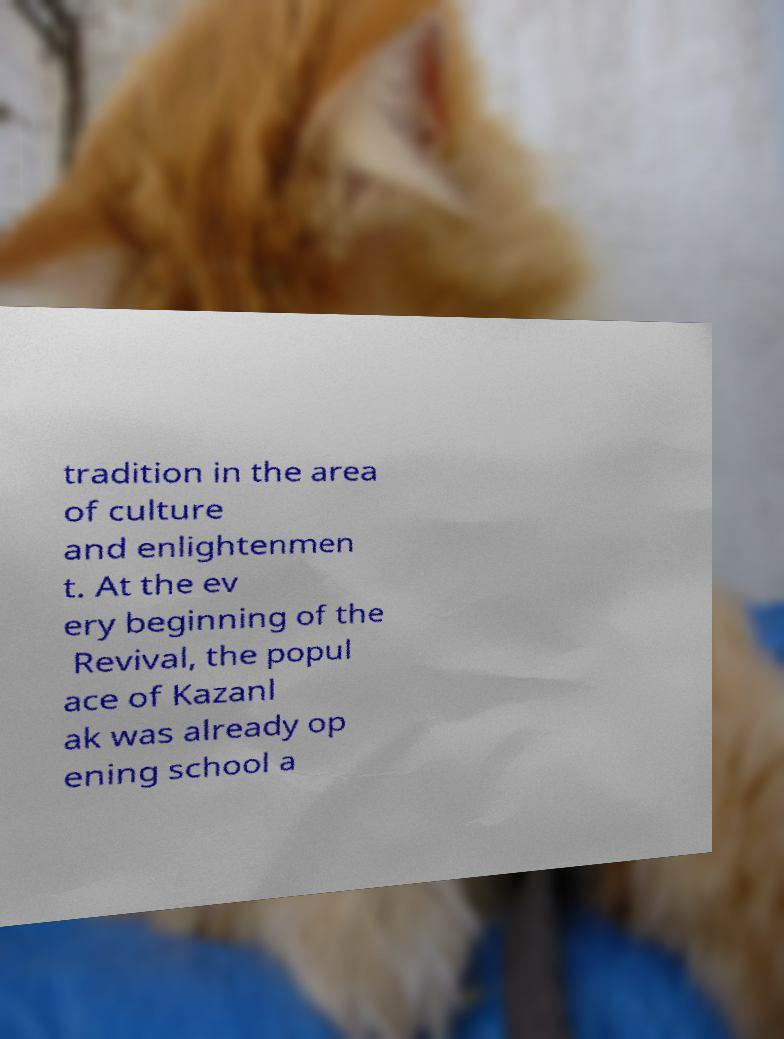What messages or text are displayed in this image? I need them in a readable, typed format. tradition in the area of culture and enlightenmen t. At the ev ery beginning of the Revival, the popul ace of Kazanl ak was already op ening school a 